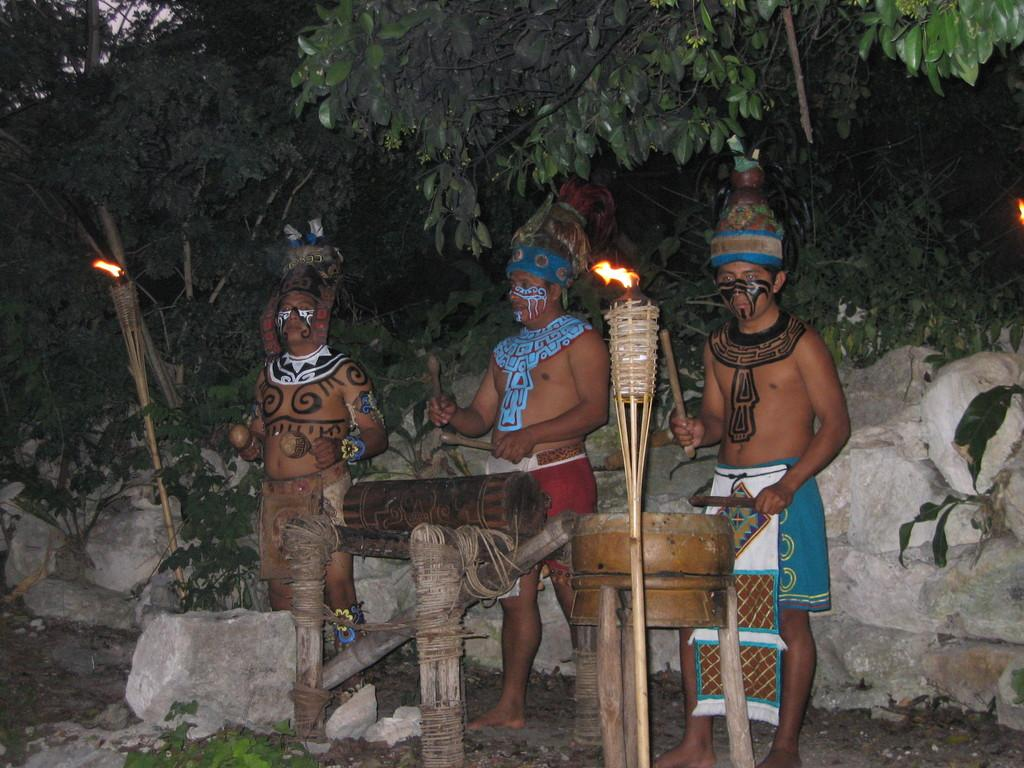How many people are in the image? There are three persons in the image. What are the persons doing in the image? The persons are playing drums. What can be seen in the middle of the image? There is fire in the middle of the image. What type of vegetation is visible at the top of the image? There are trees visible at the top of the image. What type of grass is being used as a sheet to cover the drums in the image? There is no grass or sheet present in the image, and the drums are not covered. 